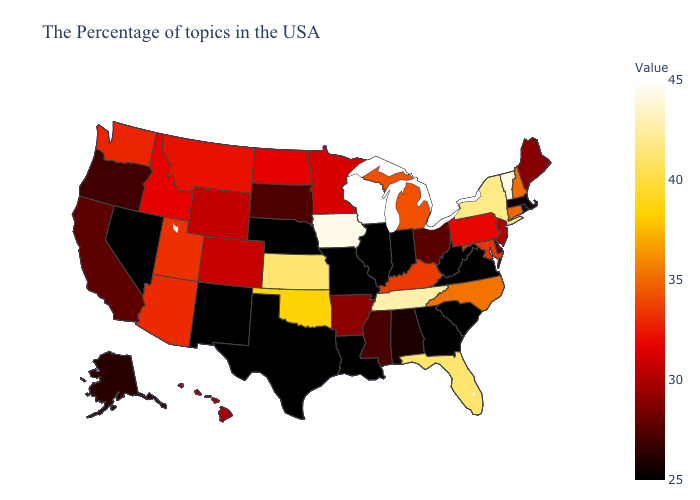Among the states that border Washington , which have the highest value?
Quick response, please. Idaho. Which states have the lowest value in the MidWest?
Be succinct. Indiana, Illinois, Missouri, Nebraska. Does Michigan have a higher value than Indiana?
Write a very short answer. Yes. Which states hav the highest value in the Northeast?
Write a very short answer. Vermont. Among the states that border Arkansas , which have the lowest value?
Answer briefly. Louisiana, Missouri, Texas. Is the legend a continuous bar?
Quick response, please. Yes. Among the states that border Vermont , does New York have the highest value?
Give a very brief answer. Yes. Is the legend a continuous bar?
Concise answer only. Yes. Does Utah have the highest value in the West?
Short answer required. Yes. 